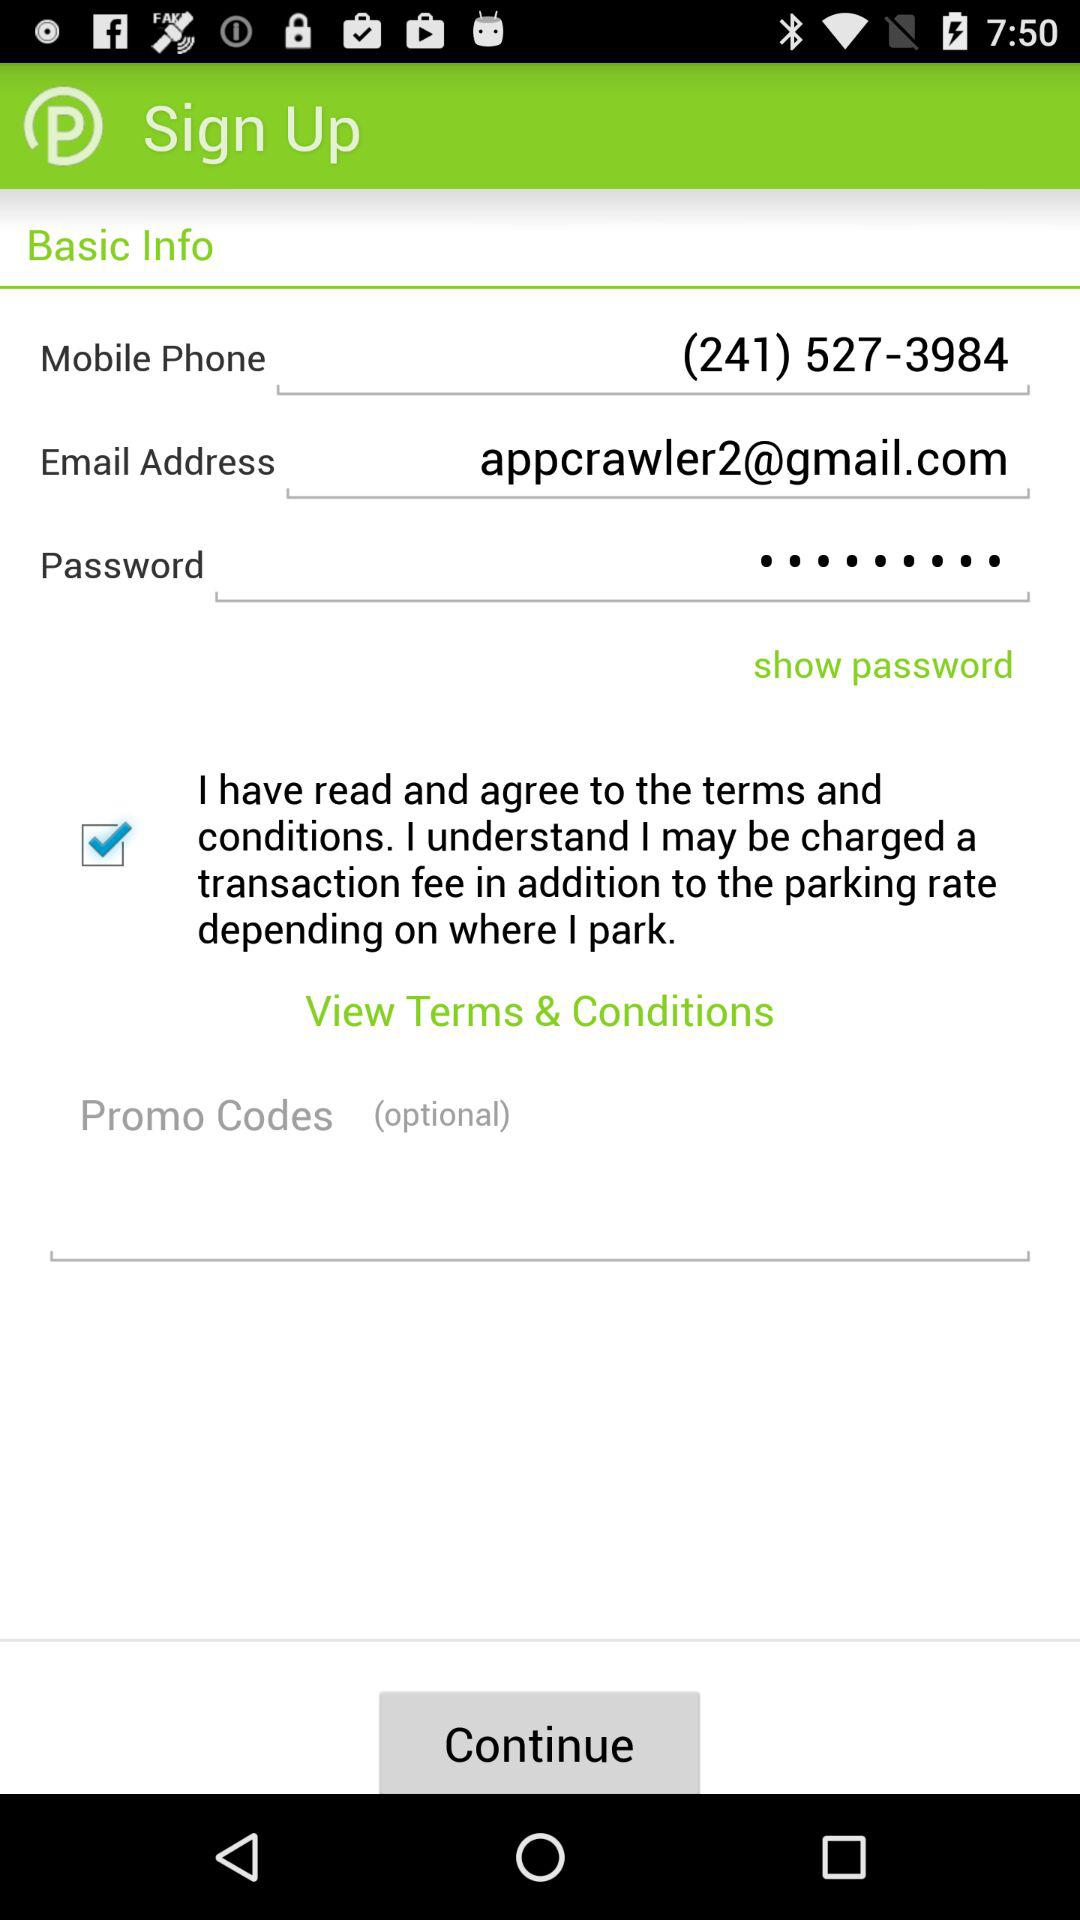Is "I have read and agree to the terms and conditions" checked or unchecked? "I have read and agree to the terms and conditions" is checked. 